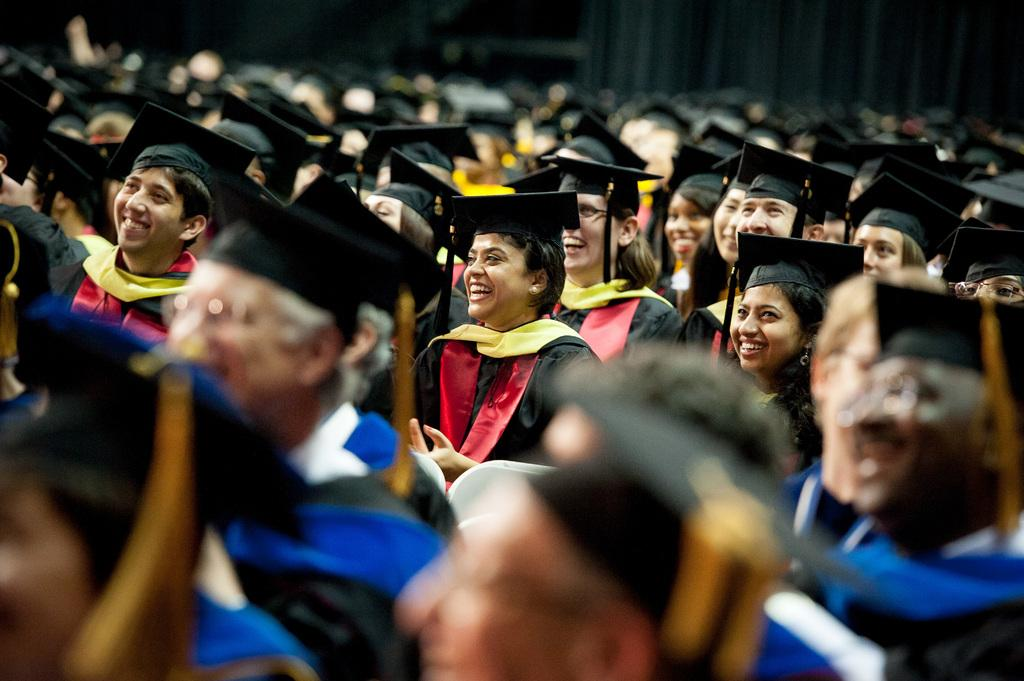What is the main subject of the image? The main subject of the image is a group of people. What are the people wearing in the image? The people are wearing convocation dress. What are the people doing in the image? The people are sitting on chairs. Where is the image taken? The setting is a closed auditorium. How many coats are hanging on the bed in the image? There is no bed or coat present in the image. What is the distance between the people in the image? The distance between the people cannot be determined from the image, as they are sitting on chairs in close proximity. 